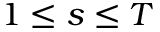Convert formula to latex. <formula><loc_0><loc_0><loc_500><loc_500>1 \leq s \leq T</formula> 